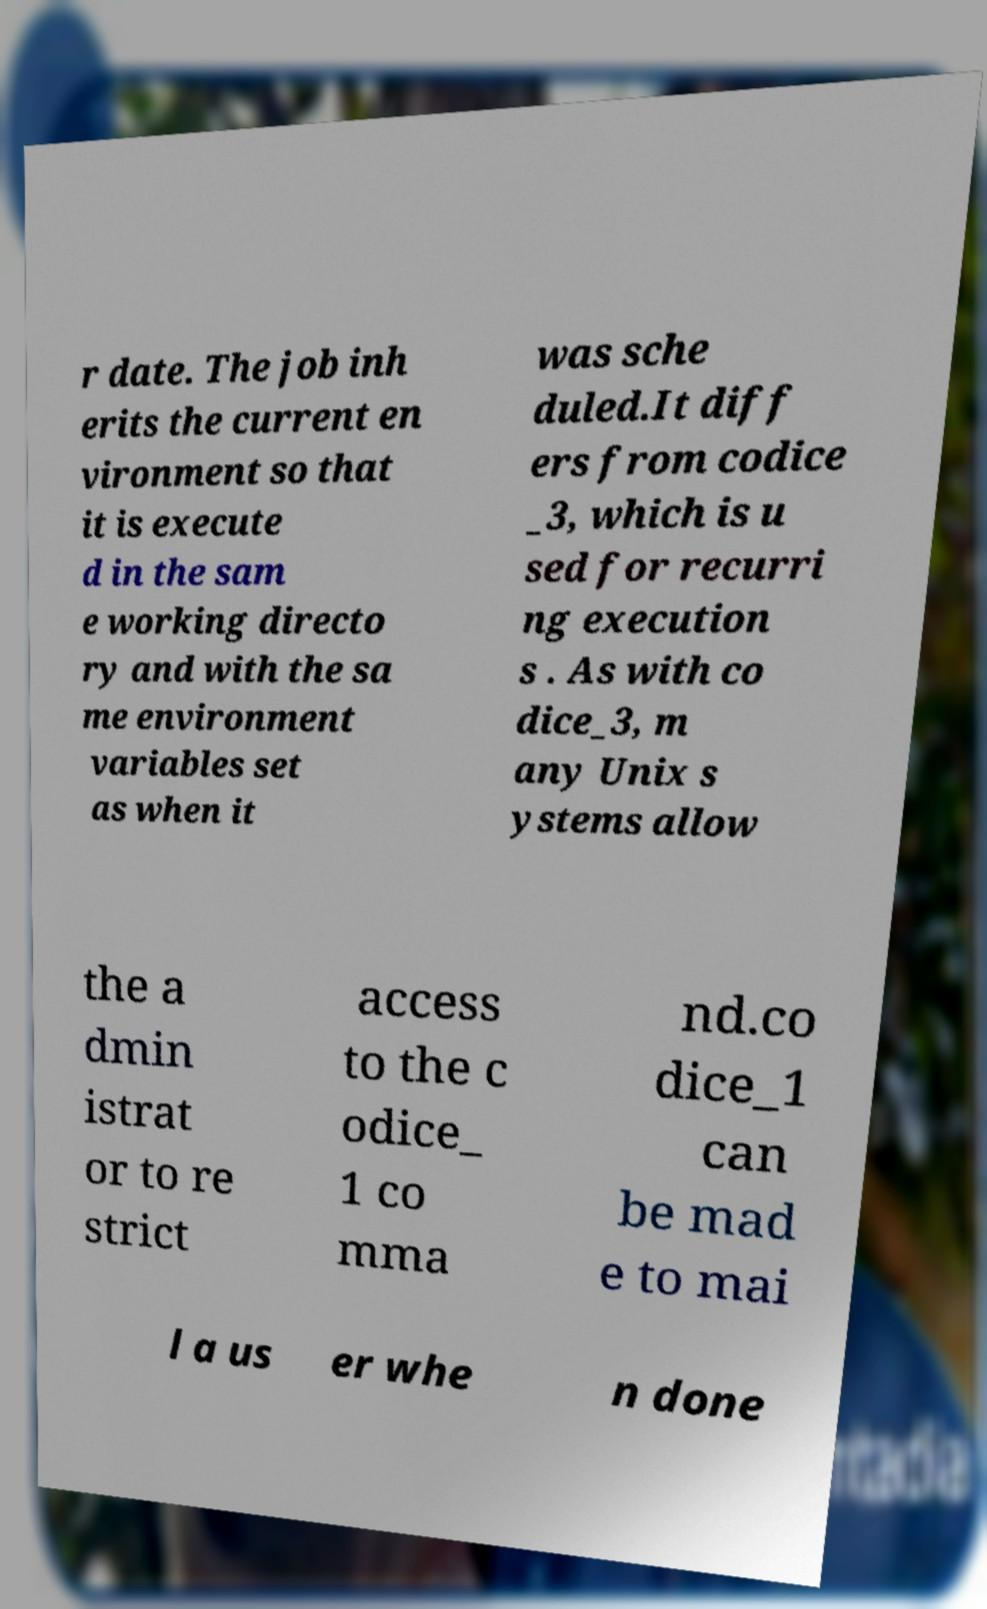Could you assist in decoding the text presented in this image and type it out clearly? r date. The job inh erits the current en vironment so that it is execute d in the sam e working directo ry and with the sa me environment variables set as when it was sche duled.It diff ers from codice _3, which is u sed for recurri ng execution s . As with co dice_3, m any Unix s ystems allow the a dmin istrat or to re strict access to the c odice_ 1 co mma nd.co dice_1 can be mad e to mai l a us er whe n done 